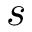<formula> <loc_0><loc_0><loc_500><loc_500>s</formula> 